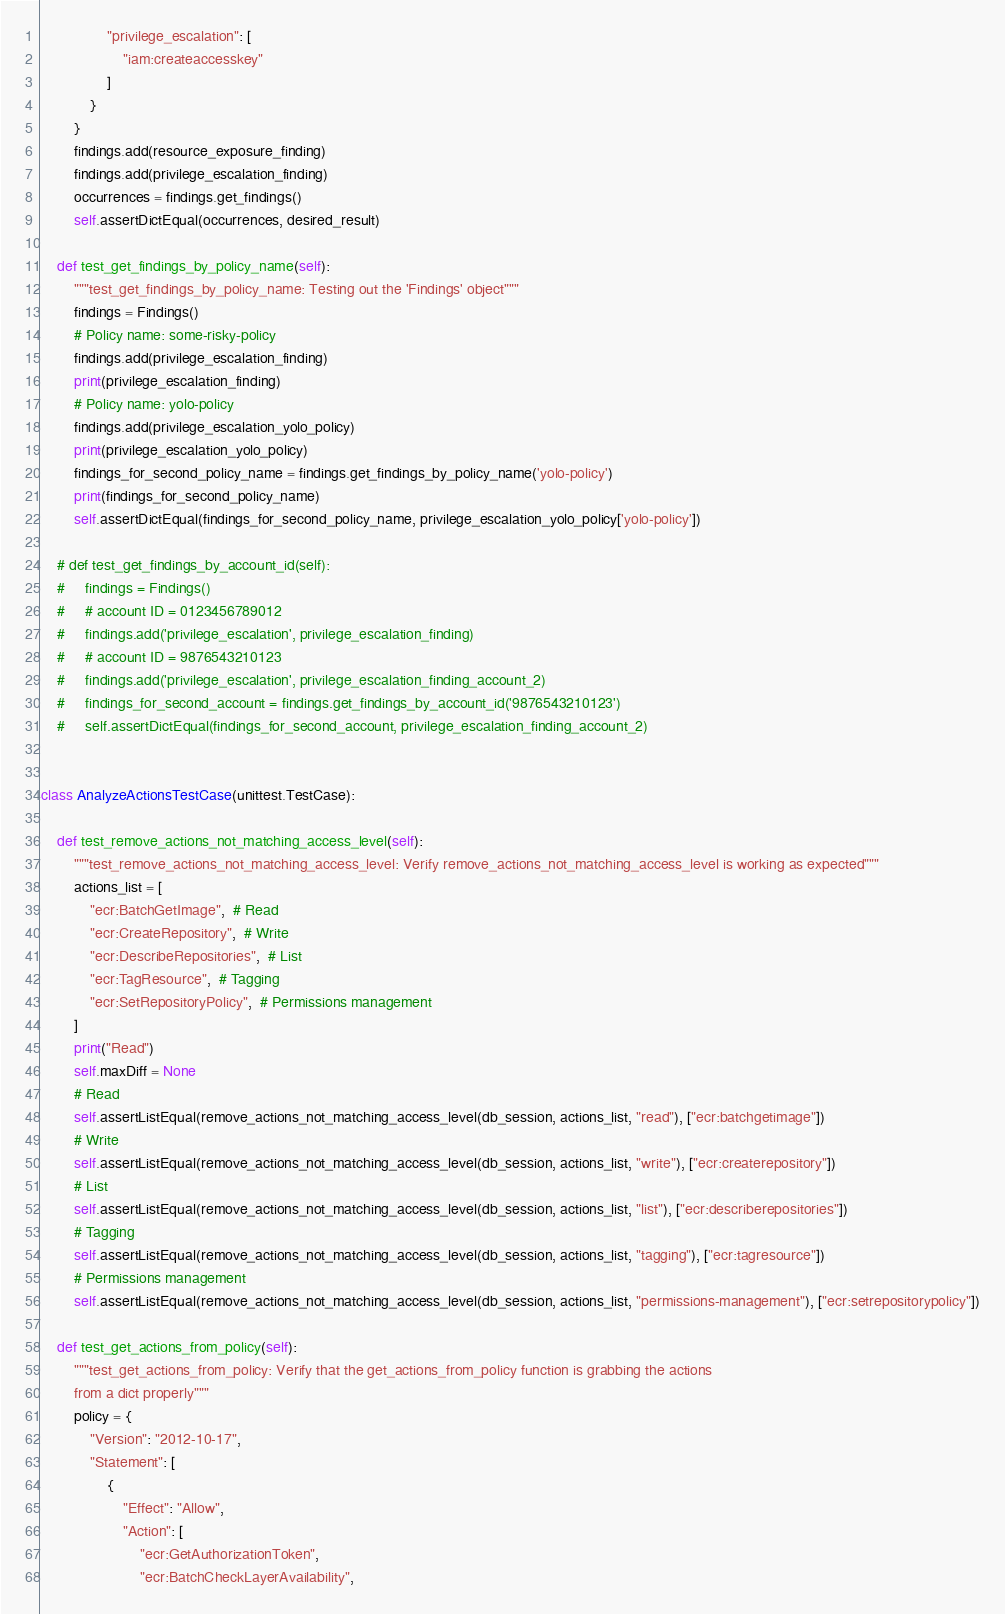<code> <loc_0><loc_0><loc_500><loc_500><_Python_>                "privilege_escalation": [
                    "iam:createaccesskey"
                ]
            }
        }
        findings.add(resource_exposure_finding)
        findings.add(privilege_escalation_finding)
        occurrences = findings.get_findings()
        self.assertDictEqual(occurrences, desired_result)

    def test_get_findings_by_policy_name(self):
        """test_get_findings_by_policy_name: Testing out the 'Findings' object"""
        findings = Findings()
        # Policy name: some-risky-policy
        findings.add(privilege_escalation_finding)
        print(privilege_escalation_finding)
        # Policy name: yolo-policy
        findings.add(privilege_escalation_yolo_policy)
        print(privilege_escalation_yolo_policy)
        findings_for_second_policy_name = findings.get_findings_by_policy_name('yolo-policy')
        print(findings_for_second_policy_name)
        self.assertDictEqual(findings_for_second_policy_name, privilege_escalation_yolo_policy['yolo-policy'])

    # def test_get_findings_by_account_id(self):
    #     findings = Findings()
    #     # account ID = 0123456789012
    #     findings.add('privilege_escalation', privilege_escalation_finding)
    #     # account ID = 9876543210123
    #     findings.add('privilege_escalation', privilege_escalation_finding_account_2)
    #     findings_for_second_account = findings.get_findings_by_account_id('9876543210123')
    #     self.assertDictEqual(findings_for_second_account, privilege_escalation_finding_account_2)


class AnalyzeActionsTestCase(unittest.TestCase):

    def test_remove_actions_not_matching_access_level(self):
        """test_remove_actions_not_matching_access_level: Verify remove_actions_not_matching_access_level is working as expected"""
        actions_list = [
            "ecr:BatchGetImage",  # Read
            "ecr:CreateRepository",  # Write
            "ecr:DescribeRepositories",  # List
            "ecr:TagResource",  # Tagging
            "ecr:SetRepositoryPolicy",  # Permissions management
        ]
        print("Read")
        self.maxDiff = None
        # Read
        self.assertListEqual(remove_actions_not_matching_access_level(db_session, actions_list, "read"), ["ecr:batchgetimage"])
        # Write
        self.assertListEqual(remove_actions_not_matching_access_level(db_session, actions_list, "write"), ["ecr:createrepository"])
        # List
        self.assertListEqual(remove_actions_not_matching_access_level(db_session, actions_list, "list"), ["ecr:describerepositories"])
        # Tagging
        self.assertListEqual(remove_actions_not_matching_access_level(db_session, actions_list, "tagging"), ["ecr:tagresource"])
        # Permissions management
        self.assertListEqual(remove_actions_not_matching_access_level(db_session, actions_list, "permissions-management"), ["ecr:setrepositorypolicy"])

    def test_get_actions_from_policy(self):
        """test_get_actions_from_policy: Verify that the get_actions_from_policy function is grabbing the actions
        from a dict properly"""
        policy = {
            "Version": "2012-10-17",
            "Statement": [
                {
                    "Effect": "Allow",
                    "Action": [
                        "ecr:GetAuthorizationToken",
                        "ecr:BatchCheckLayerAvailability",</code> 